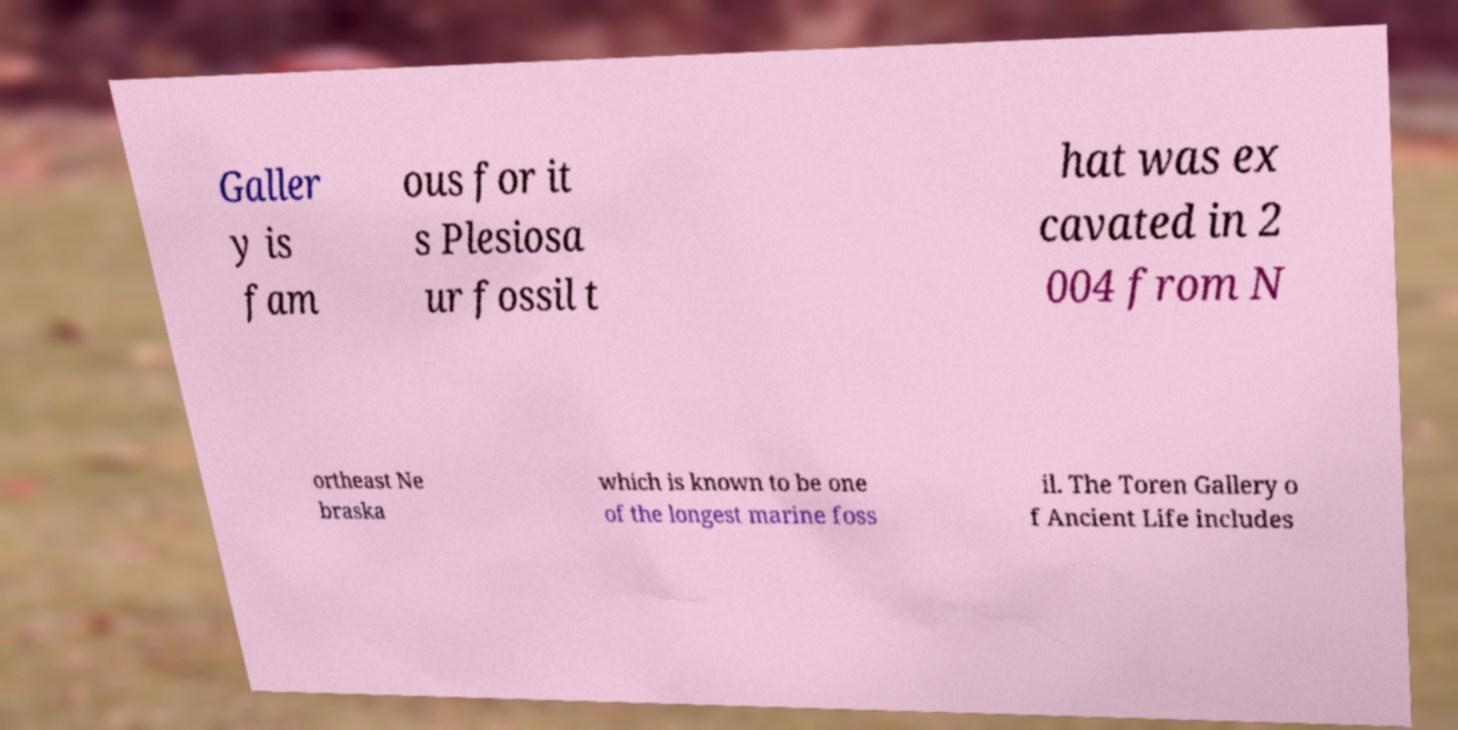Please read and relay the text visible in this image. What does it say? Galler y is fam ous for it s Plesiosa ur fossil t hat was ex cavated in 2 004 from N ortheast Ne braska which is known to be one of the longest marine foss il. The Toren Gallery o f Ancient Life includes 